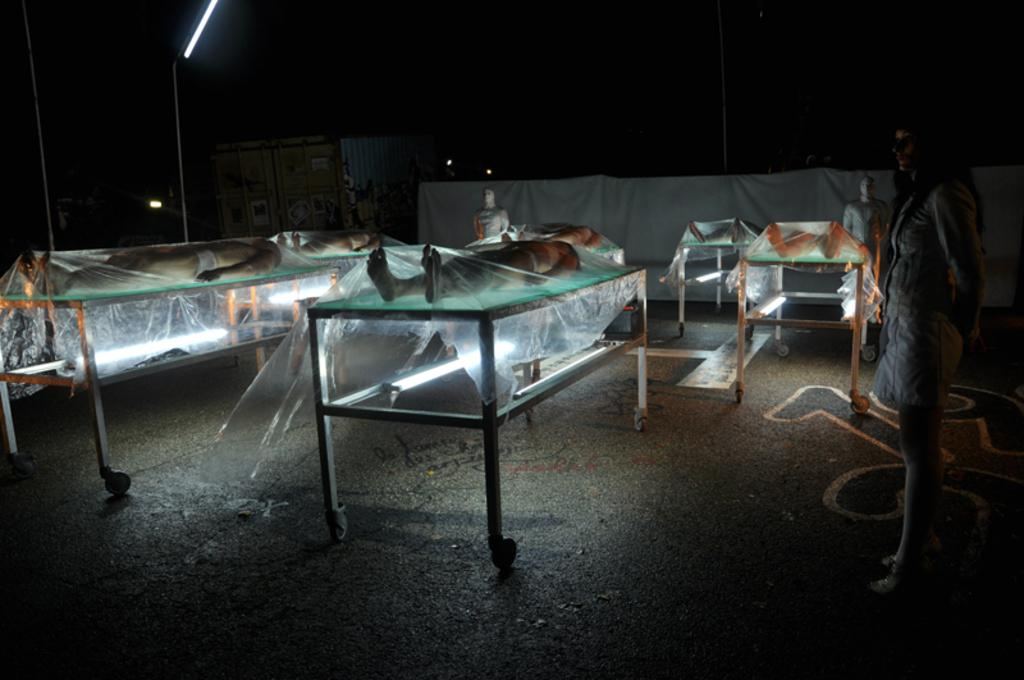What is the main subject of the image? The main subject of the image is a group of dead bodies. How are the dead bodies arranged in the image? The dead bodies are on stretchers in the image. What is used to cover the dead bodies? The dead bodies are covered with plastic covers in the image. Can you describe the person standing in the image? There is a woman standing at the right side of the image. What position does the woman show in the image? The image does not depict the woman showing any specific position; she is simply standing at the right side of the image. Is there a house visible in the image? No, there is no house visible in the image; it primarily features the group of dead bodies and the woman standing nearby. 